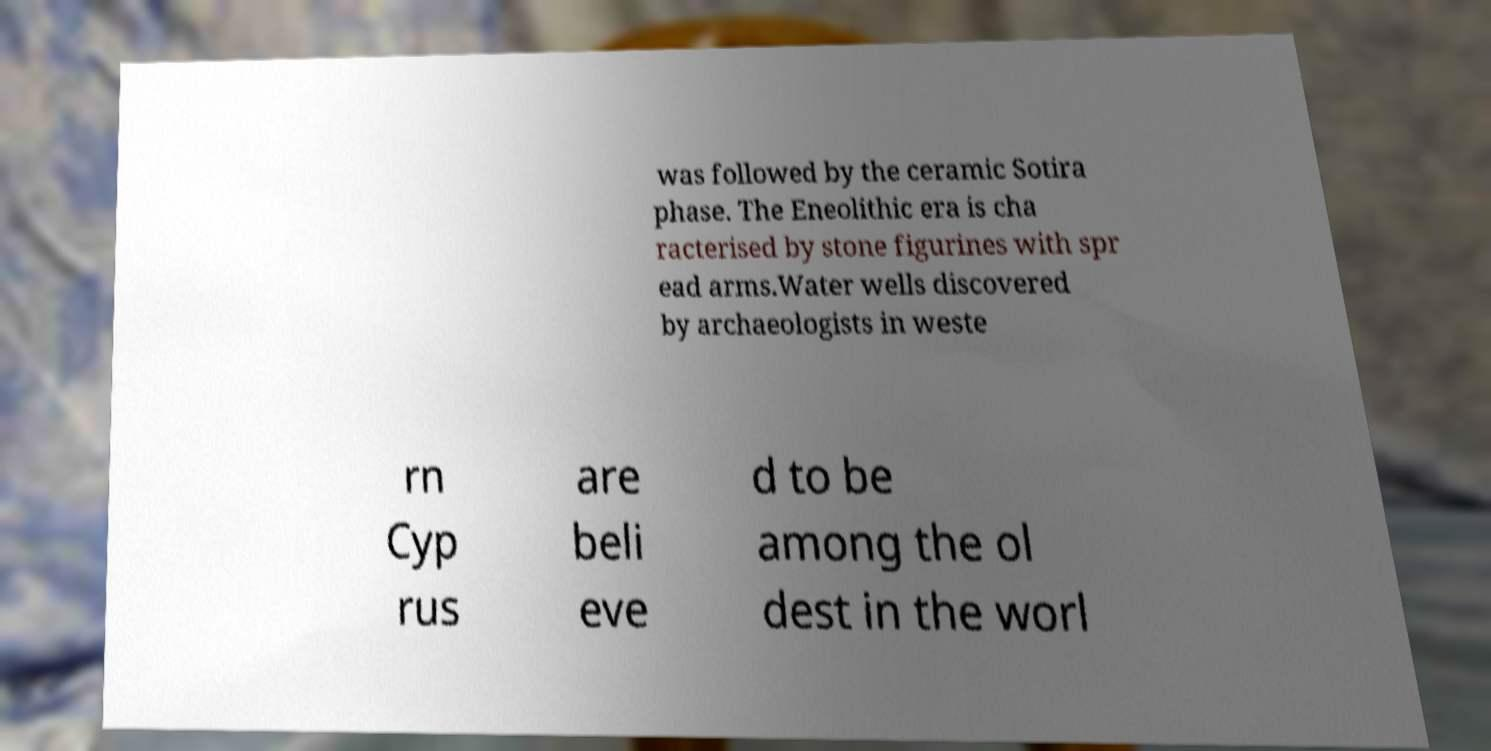Could you assist in decoding the text presented in this image and type it out clearly? was followed by the ceramic Sotira phase. The Eneolithic era is cha racterised by stone figurines with spr ead arms.Water wells discovered by archaeologists in weste rn Cyp rus are beli eve d to be among the ol dest in the worl 